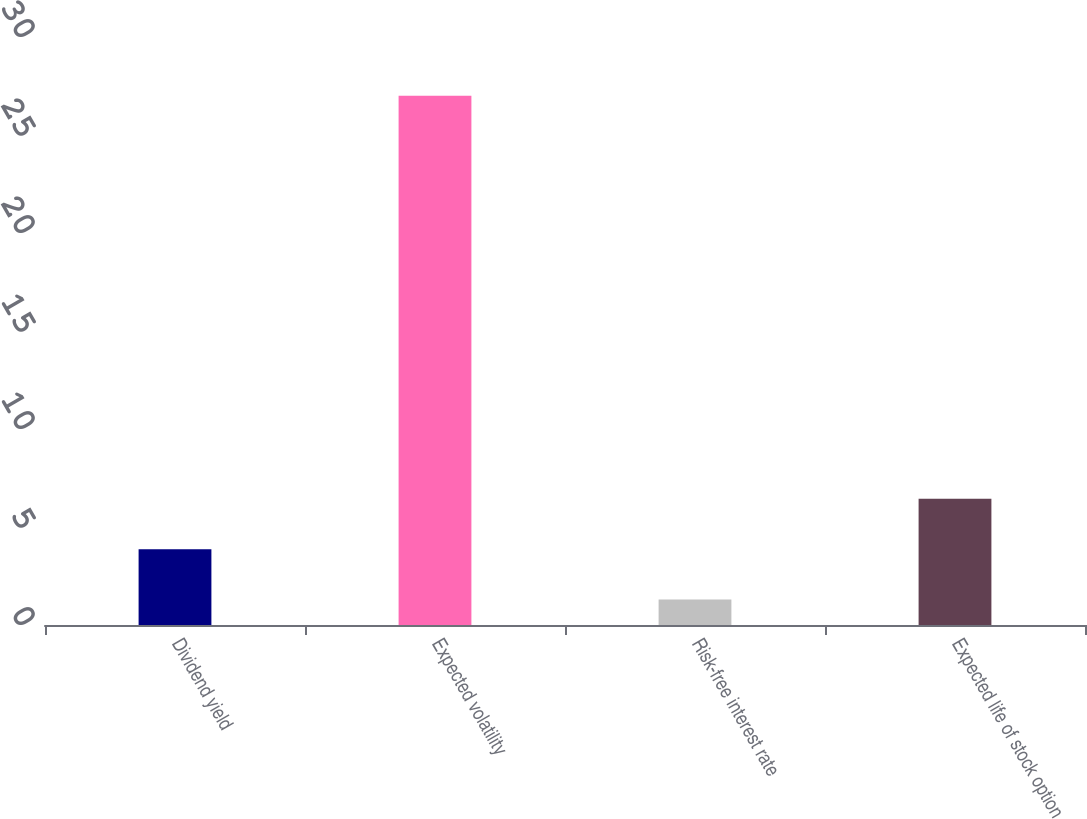<chart> <loc_0><loc_0><loc_500><loc_500><bar_chart><fcel>Dividend yield<fcel>Expected volatility<fcel>Risk-free interest rate<fcel>Expected life of stock option<nl><fcel>3.87<fcel>27<fcel>1.3<fcel>6.44<nl></chart> 